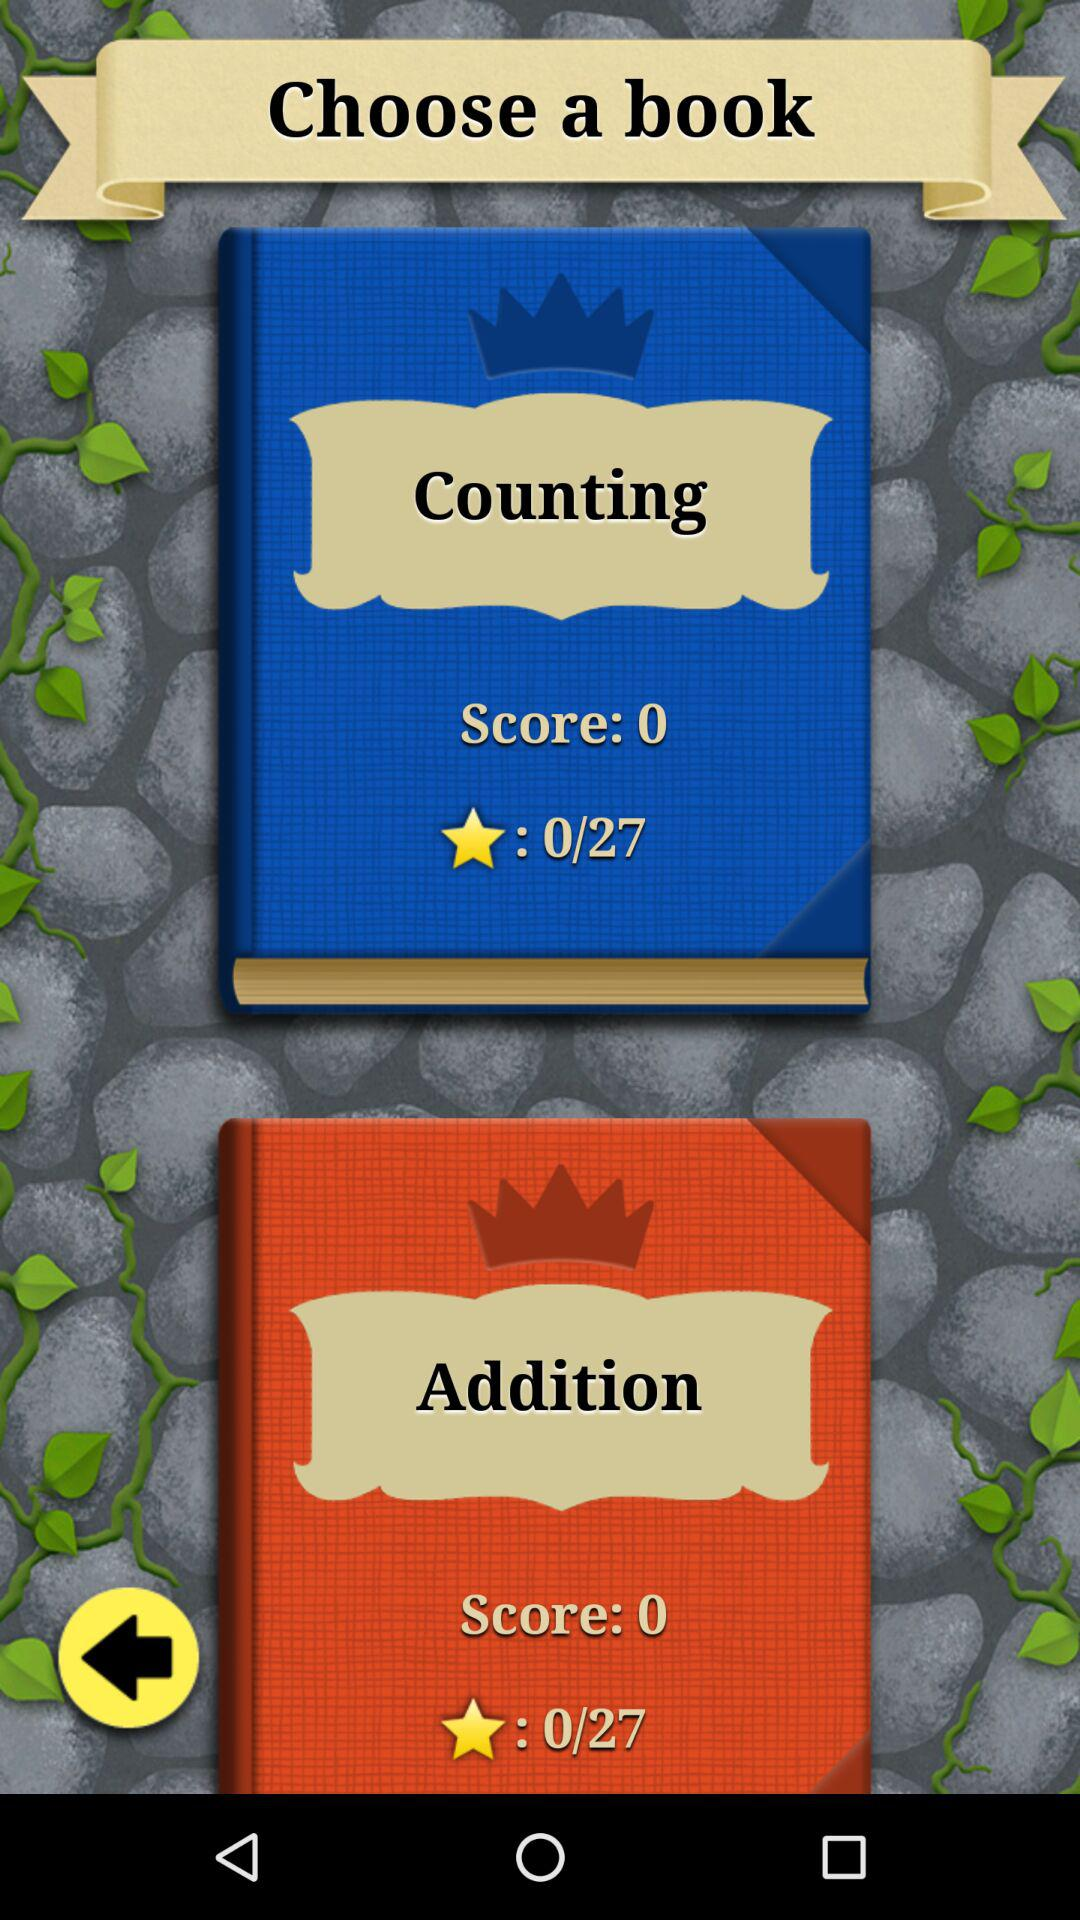What is the score of the book "Counting"? The score of the book "Counting" is 0. 